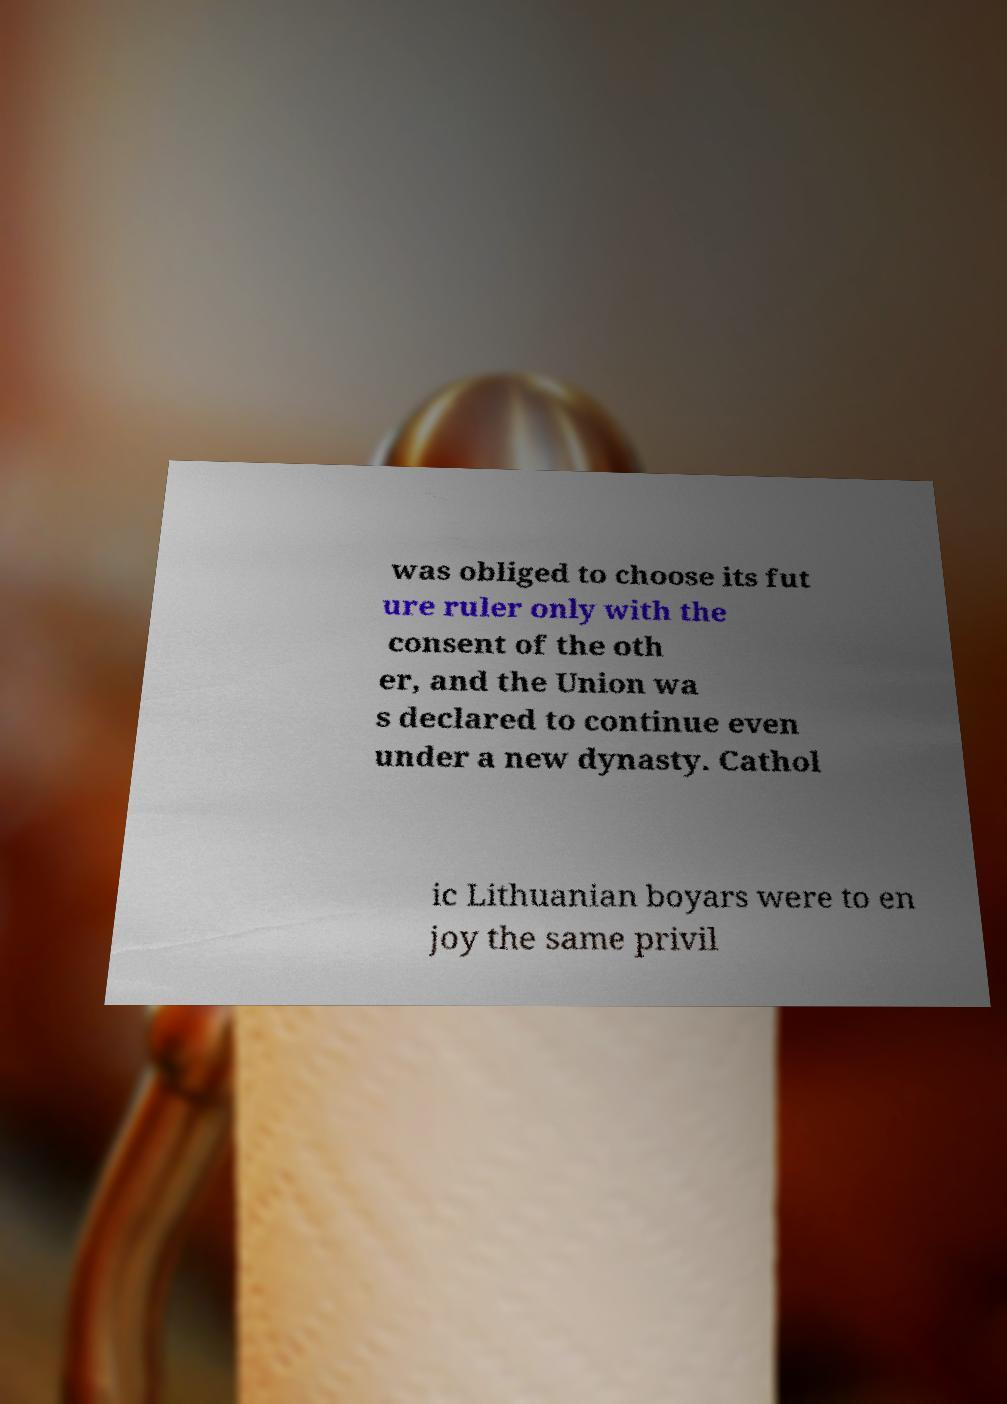Please read and relay the text visible in this image. What does it say? was obliged to choose its fut ure ruler only with the consent of the oth er, and the Union wa s declared to continue even under a new dynasty. Cathol ic Lithuanian boyars were to en joy the same privil 